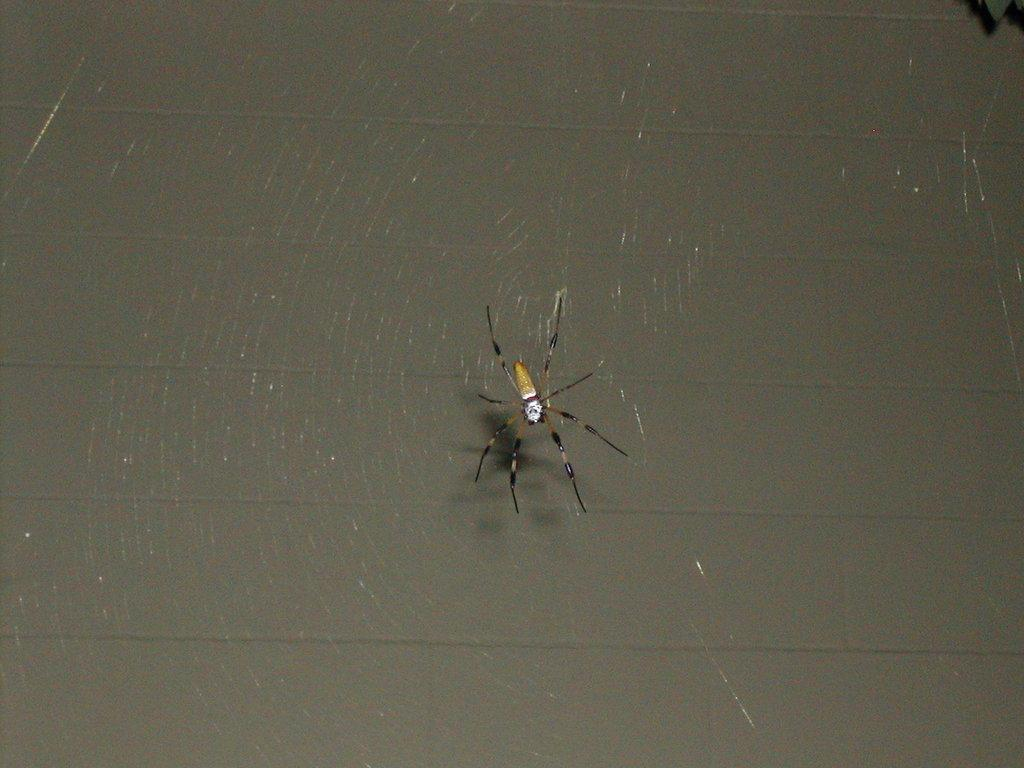What is the main subject of the image? The main subject of the image is a spider. Where is the spider located in the image? The spider is in a spider web. What can be seen in the background of the image? There is a wall visible in the background of the image. What type of tooth is visible in the image? There is no tooth present in the image; it features a spider in a spider web with a wall visible in the background. 